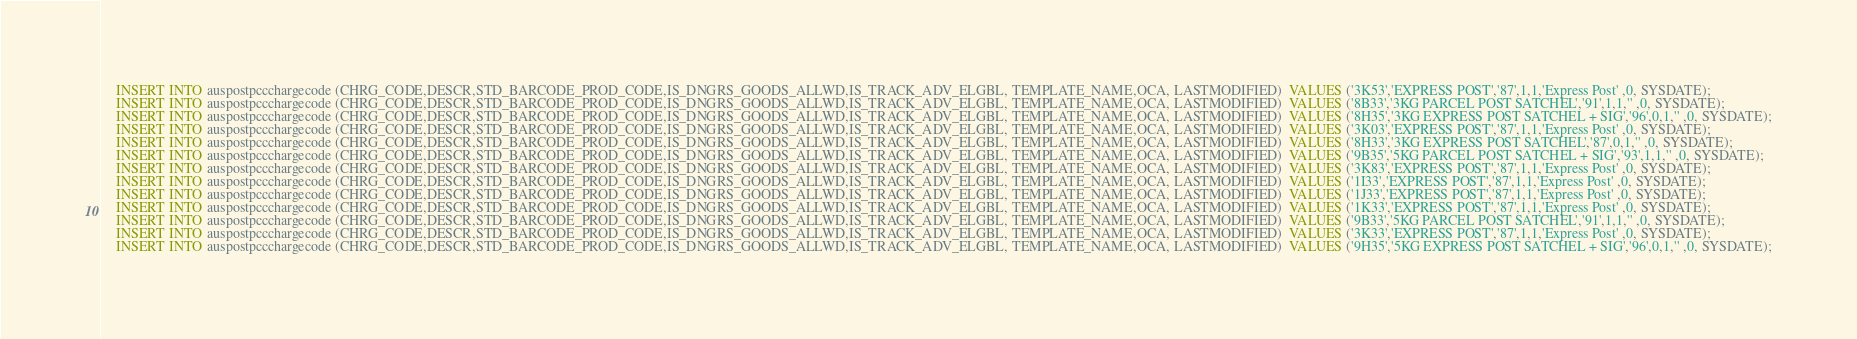<code> <loc_0><loc_0><loc_500><loc_500><_SQL_>	INSERT INTO auspostpccchargecode (CHRG_CODE,DESCR,STD_BARCODE_PROD_CODE,IS_DNGRS_GOODS_ALLWD,IS_TRACK_ADV_ELGBL, TEMPLATE_NAME,OCA, LASTMODIFIED)  VALUES ('3K53','EXPRESS POST','87',1,1,'Express Post' ,0, SYSDATE);
	INSERT INTO auspostpccchargecode (CHRG_CODE,DESCR,STD_BARCODE_PROD_CODE,IS_DNGRS_GOODS_ALLWD,IS_TRACK_ADV_ELGBL, TEMPLATE_NAME,OCA, LASTMODIFIED)  VALUES ('8B33','3KG PARCEL POST SATCHEL','91',1,1,'' ,0, SYSDATE);
	INSERT INTO auspostpccchargecode (CHRG_CODE,DESCR,STD_BARCODE_PROD_CODE,IS_DNGRS_GOODS_ALLWD,IS_TRACK_ADV_ELGBL, TEMPLATE_NAME,OCA, LASTMODIFIED)  VALUES ('8H35','3KG EXPRESS POST SATCHEL + SIG','96',0,1,'' ,0, SYSDATE);
	INSERT INTO auspostpccchargecode (CHRG_CODE,DESCR,STD_BARCODE_PROD_CODE,IS_DNGRS_GOODS_ALLWD,IS_TRACK_ADV_ELGBL, TEMPLATE_NAME,OCA, LASTMODIFIED)  VALUES ('3K03','EXPRESS POST','87',1,1,'Express Post' ,0, SYSDATE);
	INSERT INTO auspostpccchargecode (CHRG_CODE,DESCR,STD_BARCODE_PROD_CODE,IS_DNGRS_GOODS_ALLWD,IS_TRACK_ADV_ELGBL, TEMPLATE_NAME,OCA, LASTMODIFIED)  VALUES ('8H33','3KG EXPRESS POST SATCHEL','87',0,1,'' ,0, SYSDATE);
	INSERT INTO auspostpccchargecode (CHRG_CODE,DESCR,STD_BARCODE_PROD_CODE,IS_DNGRS_GOODS_ALLWD,IS_TRACK_ADV_ELGBL, TEMPLATE_NAME,OCA, LASTMODIFIED)  VALUES ('9B35','5KG PARCEL POST SATCHEL + SIG','93',1,1,'' ,0, SYSDATE);
	INSERT INTO auspostpccchargecode (CHRG_CODE,DESCR,STD_BARCODE_PROD_CODE,IS_DNGRS_GOODS_ALLWD,IS_TRACK_ADV_ELGBL, TEMPLATE_NAME,OCA, LASTMODIFIED)  VALUES ('3K83','EXPRESS POST','87',1,1,'Express Post' ,0, SYSDATE);
	INSERT INTO auspostpccchargecode (CHRG_CODE,DESCR,STD_BARCODE_PROD_CODE,IS_DNGRS_GOODS_ALLWD,IS_TRACK_ADV_ELGBL, TEMPLATE_NAME,OCA, LASTMODIFIED)  VALUES ('1I33','EXPRESS POST','87',1,1,'Express Post' ,0, SYSDATE);
	INSERT INTO auspostpccchargecode (CHRG_CODE,DESCR,STD_BARCODE_PROD_CODE,IS_DNGRS_GOODS_ALLWD,IS_TRACK_ADV_ELGBL, TEMPLATE_NAME,OCA, LASTMODIFIED)  VALUES ('1J33','EXPRESS POST','87',1,1,'Express Post' ,0, SYSDATE);
	INSERT INTO auspostpccchargecode (CHRG_CODE,DESCR,STD_BARCODE_PROD_CODE,IS_DNGRS_GOODS_ALLWD,IS_TRACK_ADV_ELGBL, TEMPLATE_NAME,OCA, LASTMODIFIED)  VALUES ('1K33','EXPRESS POST','87',1,1,'Express Post' ,0, SYSDATE);
	INSERT INTO auspostpccchargecode (CHRG_CODE,DESCR,STD_BARCODE_PROD_CODE,IS_DNGRS_GOODS_ALLWD,IS_TRACK_ADV_ELGBL, TEMPLATE_NAME,OCA, LASTMODIFIED)  VALUES ('9B33','5KG PARCEL POST SATCHEL','91',1,1,'' ,0, SYSDATE);
	INSERT INTO auspostpccchargecode (CHRG_CODE,DESCR,STD_BARCODE_PROD_CODE,IS_DNGRS_GOODS_ALLWD,IS_TRACK_ADV_ELGBL, TEMPLATE_NAME,OCA, LASTMODIFIED)  VALUES ('3K33','EXPRESS POST','87',1,1,'Express Post' ,0, SYSDATE);
	INSERT INTO auspostpccchargecode (CHRG_CODE,DESCR,STD_BARCODE_PROD_CODE,IS_DNGRS_GOODS_ALLWD,IS_TRACK_ADV_ELGBL, TEMPLATE_NAME,OCA, LASTMODIFIED)  VALUES ('9H35','5KG EXPRESS POST SATCHEL + SIG','96',0,1,'' ,0, SYSDATE);</code> 